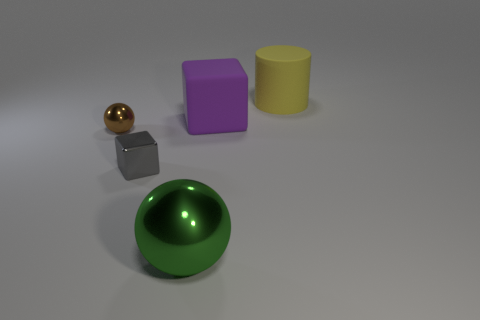Are the thing behind the big purple rubber thing and the cube that is on the left side of the big green metal sphere made of the same material?
Make the answer very short. No. What number of cubes are either objects or purple objects?
Provide a succinct answer. 2. How many metallic things are behind the big object that is in front of the sphere behind the large green metallic sphere?
Your answer should be very brief. 2. There is a purple thing that is the same shape as the tiny gray thing; what material is it?
Your answer should be very brief. Rubber. Is there anything else that has the same material as the large green object?
Your answer should be very brief. Yes. What color is the metal sphere left of the gray metallic thing?
Give a very brief answer. Brown. Is the big yellow cylinder made of the same material as the big object that is in front of the rubber block?
Offer a terse response. No. What material is the large purple block?
Make the answer very short. Rubber. There is a small brown thing that is the same material as the green sphere; what is its shape?
Your response must be concise. Sphere. How many other things are the same shape as the green object?
Offer a terse response. 1. 